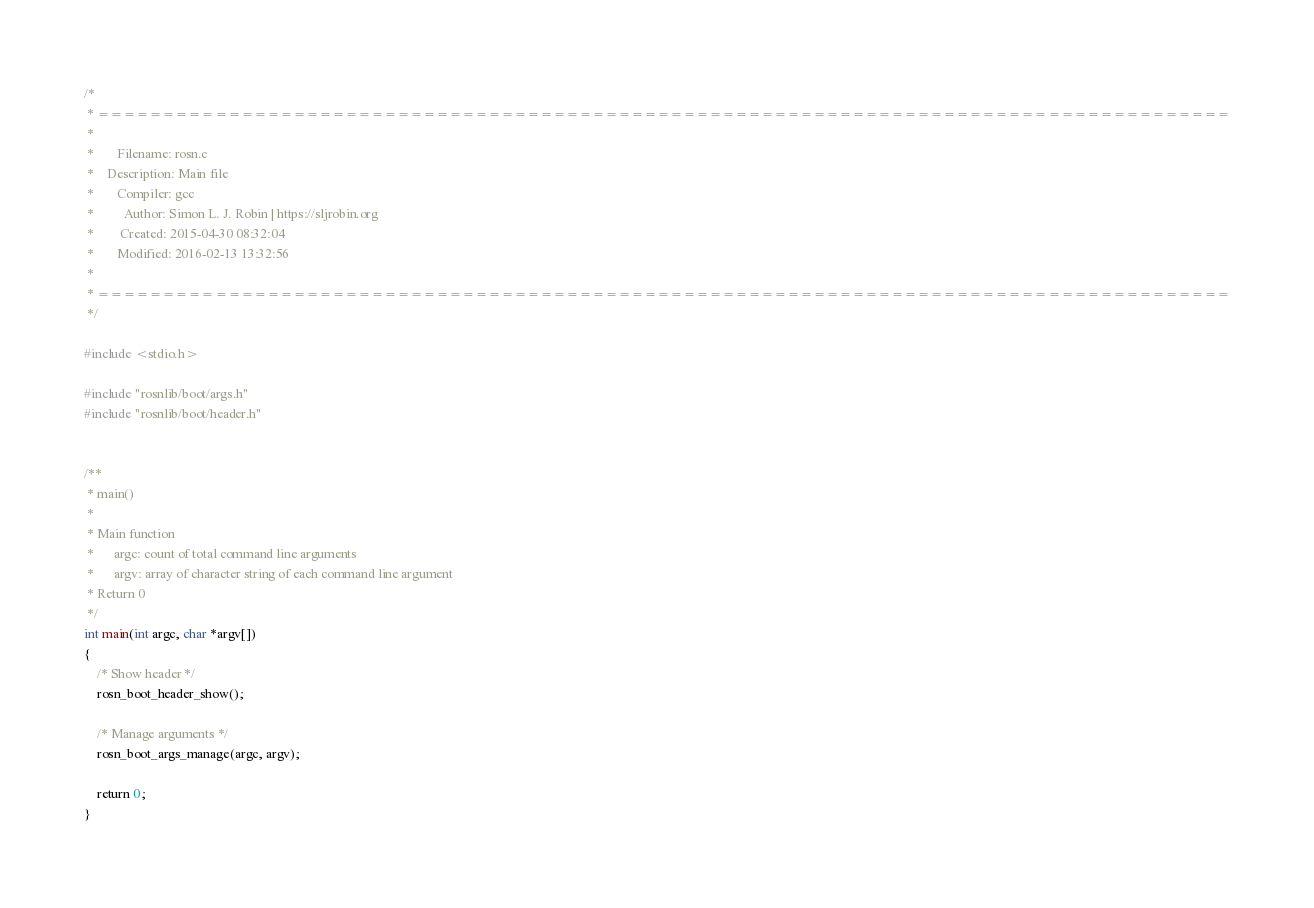<code> <loc_0><loc_0><loc_500><loc_500><_C_>/*
 * =======================================================================================
 *
 *       Filename: rosn.c
 *    Description: Main file
 *       Compiler: gcc
 *         Author: Simon L. J. Robin | https://sljrobin.org
 *        Created: 2015-04-30 08:32:04
 *       Modified: 2016-02-13 13:32:56
 *
 * =======================================================================================
 */

#include <stdio.h>

#include "rosnlib/boot/args.h"
#include "rosnlib/boot/header.h"


/** 
 * main()
 * 
 * Main function
 *      argc: count of total command line arguments 
 *      argv: array of character string of each command line argument
 * Return 0
 */
int main(int argc, char *argv[])
{
    /* Show header */
    rosn_boot_header_show();

    /* Manage arguments */
    rosn_boot_args_manage(argc, argv);

    return 0;
}
</code> 